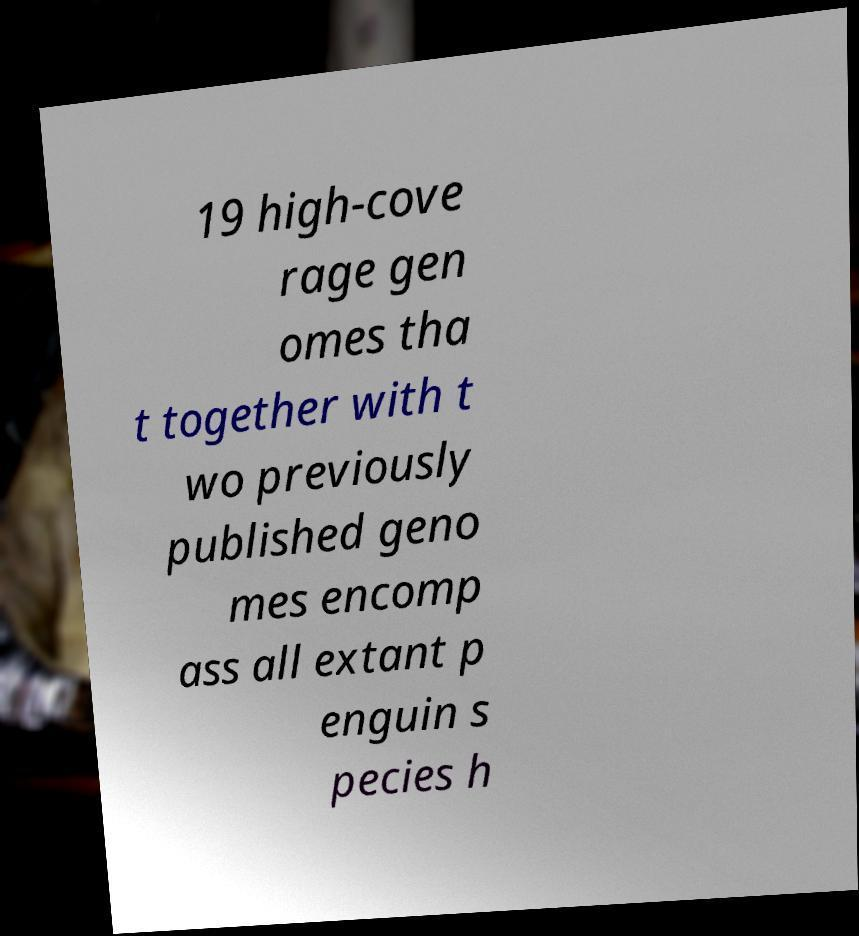Can you accurately transcribe the text from the provided image for me? 19 high-cove rage gen omes tha t together with t wo previously published geno mes encomp ass all extant p enguin s pecies h 